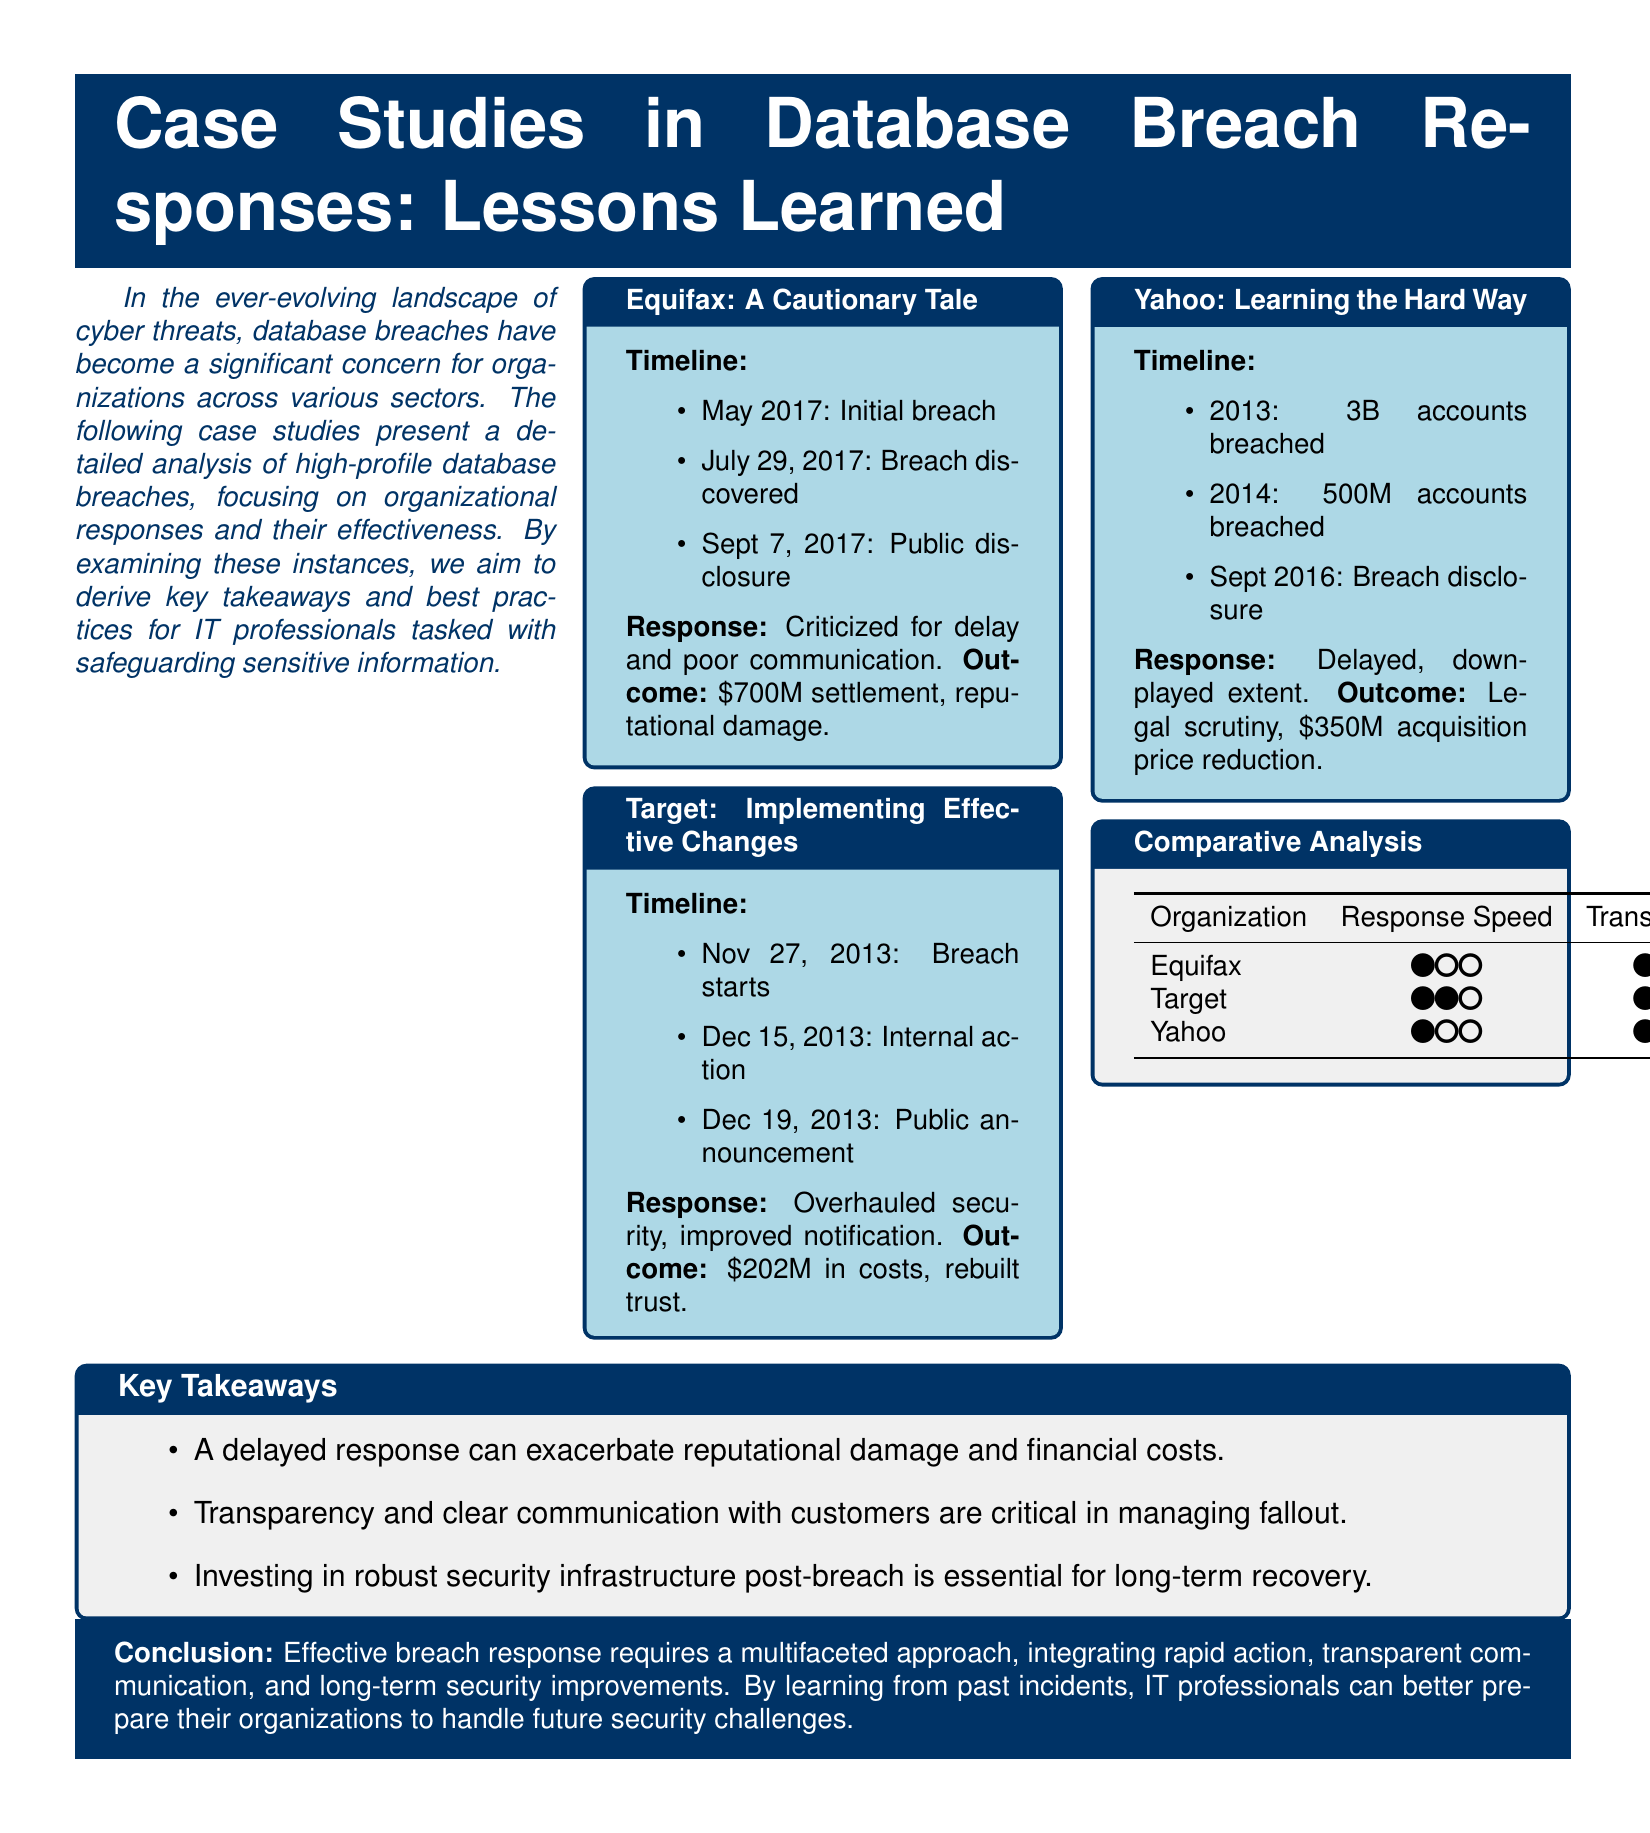What date did the Equifax breach occur? The Equifax breach occurred in May 2017 according to the timeline provided.
Answer: May 2017 How much was the settlement for Equifax? The outcome section states that the settlement amount for Equifax was $700M.
Answer: $700M What major action did Target take after their breach? The document indicates that Target overhauled their security after the breach.
Answer: Overhauled security When did Yahoo disclose their breaches? The timeline shows that Yahoo disclosed the breaches in September 2016.
Answer: September 2016 What was the outcome for Yahoo regarding their acquisition price? The outcome states that the acquisition price for Yahoo was reduced by $350M due to the breaches.
Answer: $350M Which organization was criticized for their response speed? Equifax is mentioned as being criticized for delays in their response.
Answer: Equifax Which breach response focused on transparency as a key aspect? The key takeaways section suggests that transparency is critical in managing fallout, indicating this was important for Target.
Answer: Target How many accounts were breached in Yahoo's first incident? The document notes that Yahoo had 3 billion accounts breached in 2013.
Answer: 3 billion Which company faced a total cost of $202M due to their breach? The outcome indicates that Target incurred costs totaling $202M as a result of their breach.
Answer: $202M 